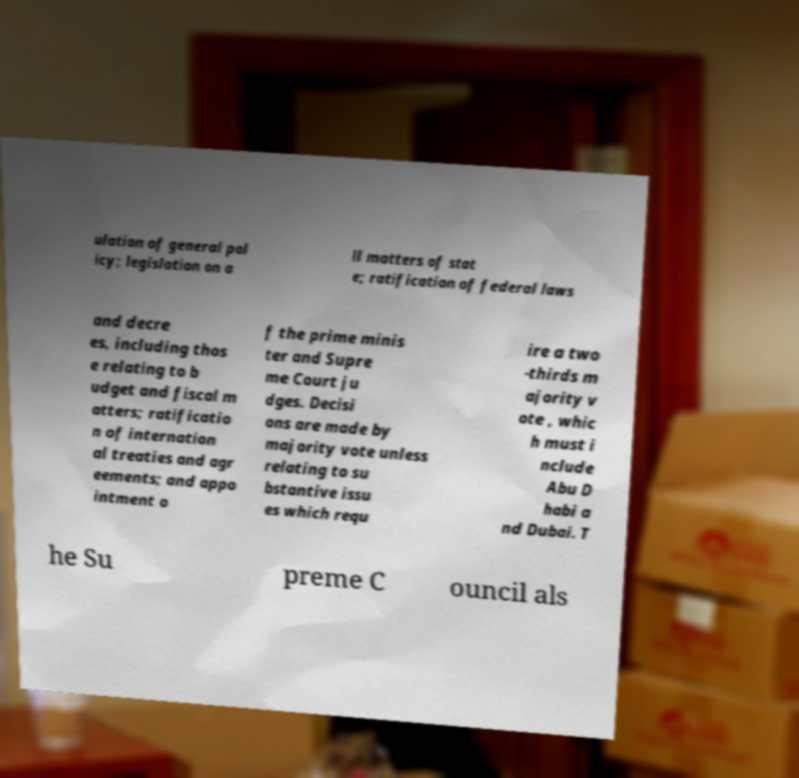I need the written content from this picture converted into text. Can you do that? ulation of general pol icy; legislation on a ll matters of stat e; ratification of federal laws and decre es, including thos e relating to b udget and fiscal m atters; ratificatio n of internation al treaties and agr eements; and appo intment o f the prime minis ter and Supre me Court ju dges. Decisi ons are made by majority vote unless relating to su bstantive issu es which requ ire a two -thirds m ajority v ote , whic h must i nclude Abu D habi a nd Dubai. T he Su preme C ouncil als 